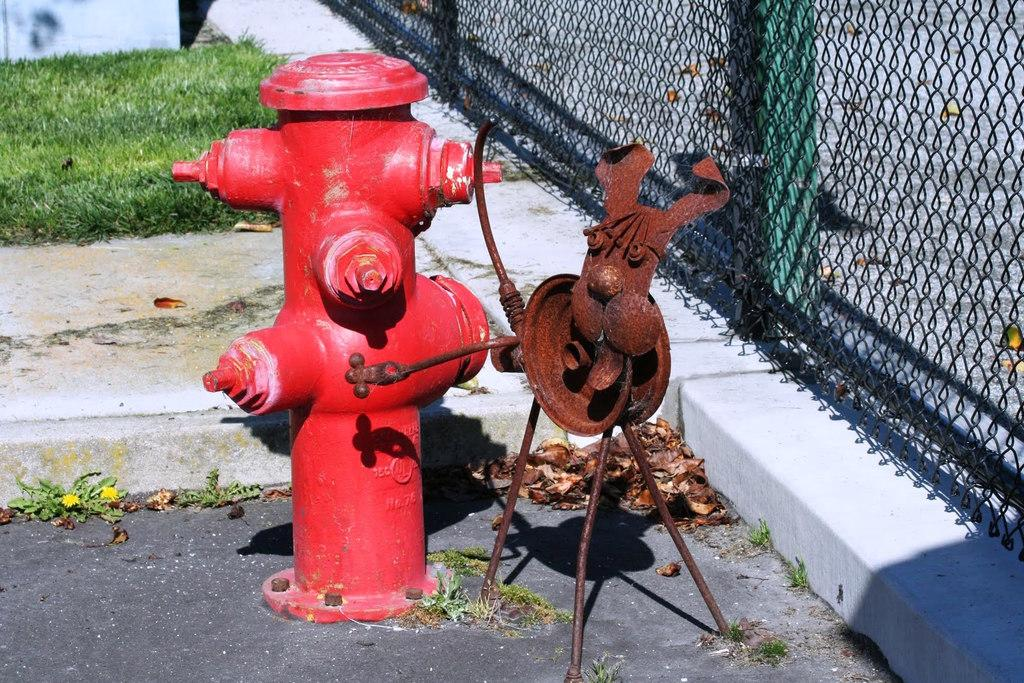What is the main object in the image? There is a fire hydrant in the image. What is located on the floor in the image? There is an object on the floor in the image. What type of barrier can be seen in the image? There is fencing in the image. What type of vegetation is visible in the background of the image? There is grass visible in the background of the image. What type of teaching method is being demonstrated with the frogs in the image? There are no frogs present in the image, so no teaching method can be observed. 